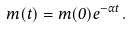Convert formula to latex. <formula><loc_0><loc_0><loc_500><loc_500>m ( t ) = m ( 0 ) e ^ { - \alpha t } \, .</formula> 